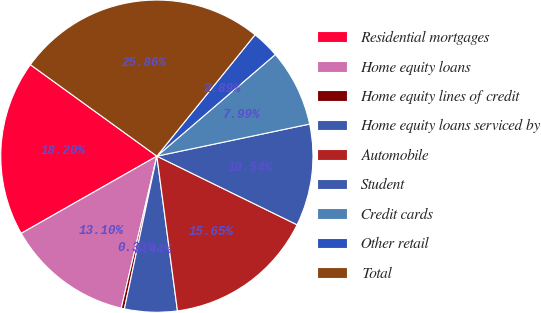Convert chart. <chart><loc_0><loc_0><loc_500><loc_500><pie_chart><fcel>Residential mortgages<fcel>Home equity loans<fcel>Home equity lines of credit<fcel>Home equity loans serviced by<fcel>Automobile<fcel>Student<fcel>Credit cards<fcel>Other retail<fcel>Total<nl><fcel>18.2%<fcel>13.1%<fcel>0.33%<fcel>5.44%<fcel>15.65%<fcel>10.54%<fcel>7.99%<fcel>2.89%<fcel>25.86%<nl></chart> 